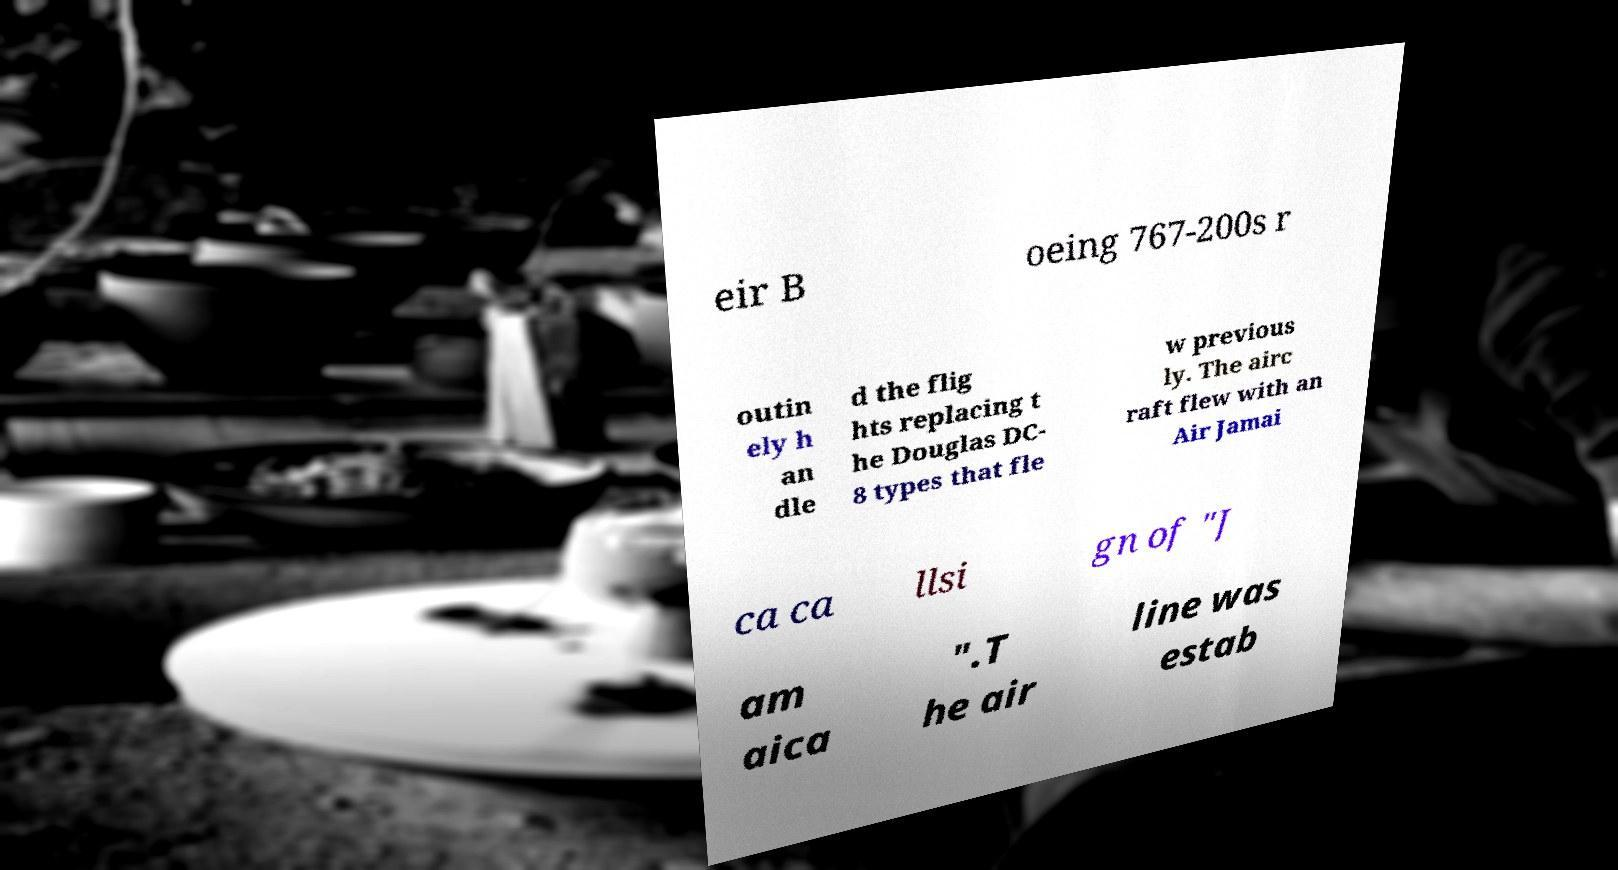What messages or text are displayed in this image? I need them in a readable, typed format. eir B oeing 767-200s r outin ely h an dle d the flig hts replacing t he Douglas DC- 8 types that fle w previous ly. The airc raft flew with an Air Jamai ca ca llsi gn of "J am aica ".T he air line was estab 